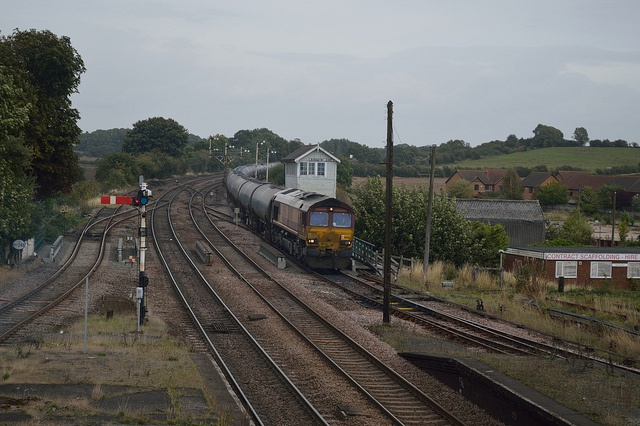Describe the objects in this image and their specific colors. I can see train in darkgray, black, gray, and maroon tones, traffic light in darkgray, black, blue, darkblue, and gray tones, and traffic light in darkgray, gray, black, and lightgray tones in this image. 